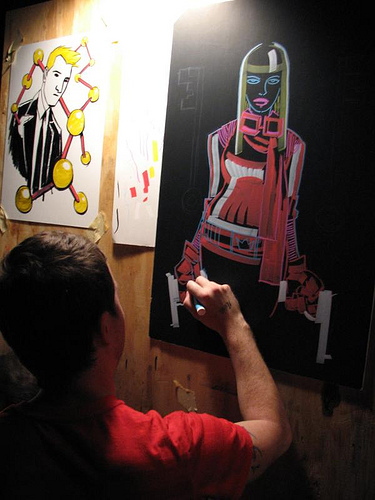<image>
Can you confirm if the man is next to the picture? Yes. The man is positioned adjacent to the picture, located nearby in the same general area. 